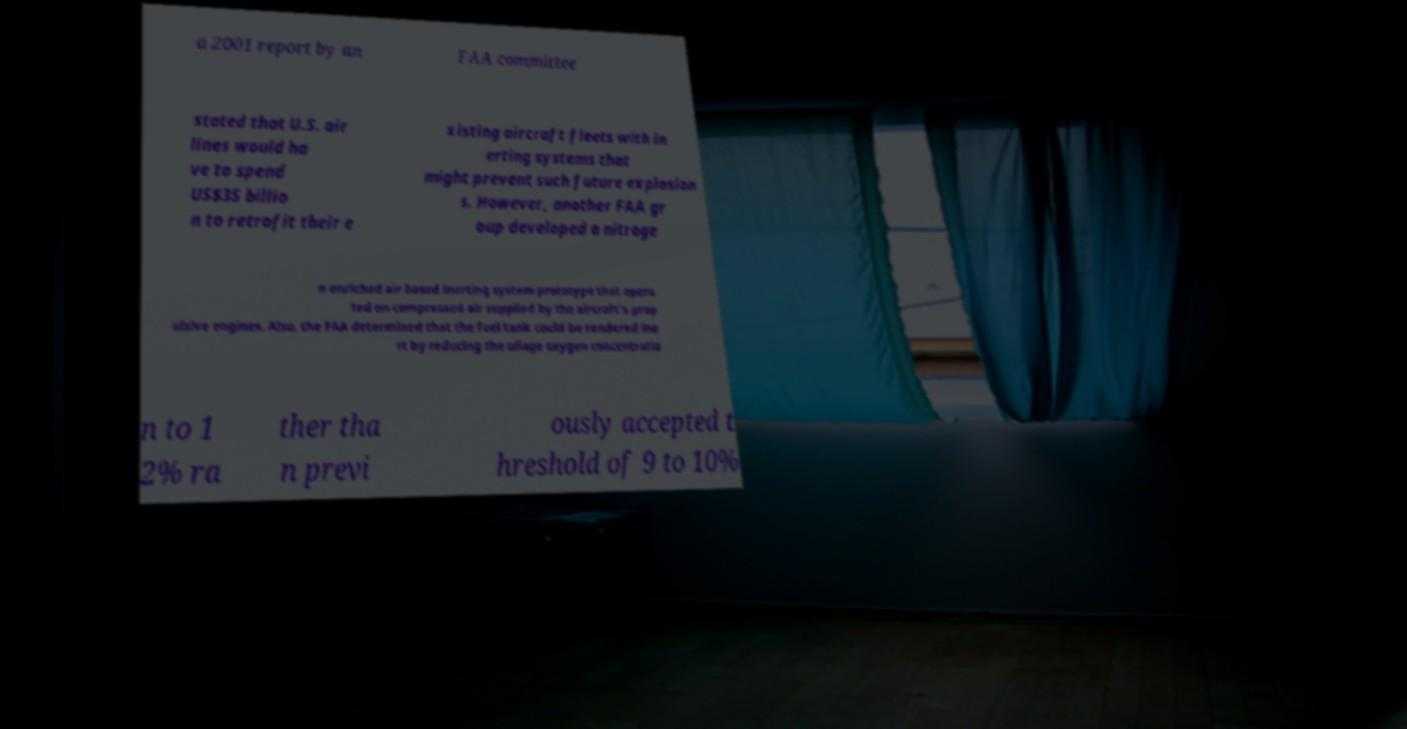Can you read and provide the text displayed in the image?This photo seems to have some interesting text. Can you extract and type it out for me? a 2001 report by an FAA committee stated that U.S. air lines would ha ve to spend US$35 billio n to retrofit their e xisting aircraft fleets with in erting systems that might prevent such future explosion s. However, another FAA gr oup developed a nitroge n enriched air based inerting system prototype that opera ted on compressed air supplied by the aircraft's prop ulsive engines. Also, the FAA determined that the fuel tank could be rendered ine rt by reducing the ullage oxygen concentratio n to 1 2% ra ther tha n previ ously accepted t hreshold of 9 to 10% 